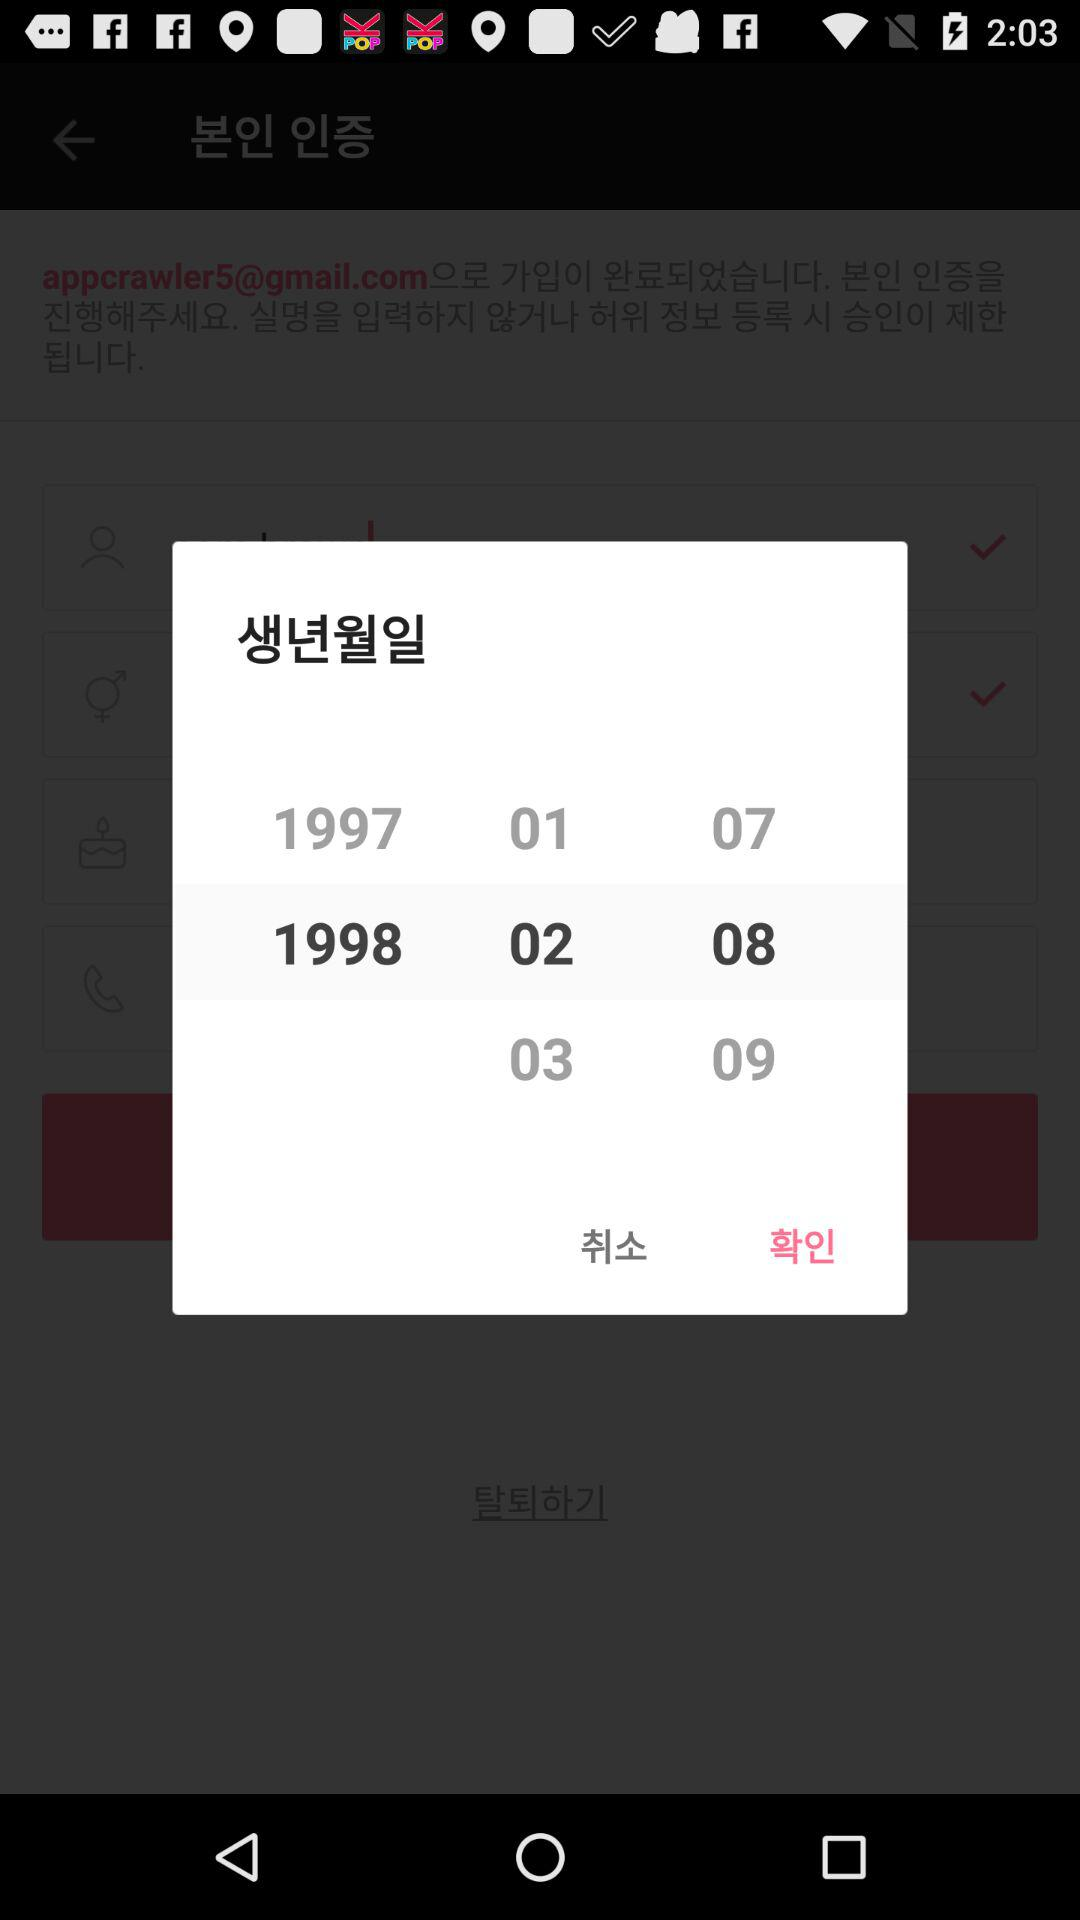How many years older is the person born in 1998 than the person born in 1997?
Answer the question using a single word or phrase. 1 